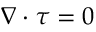Convert formula to latex. <formula><loc_0><loc_0><loc_500><loc_500>\nabla \cdot \tau = 0</formula> 